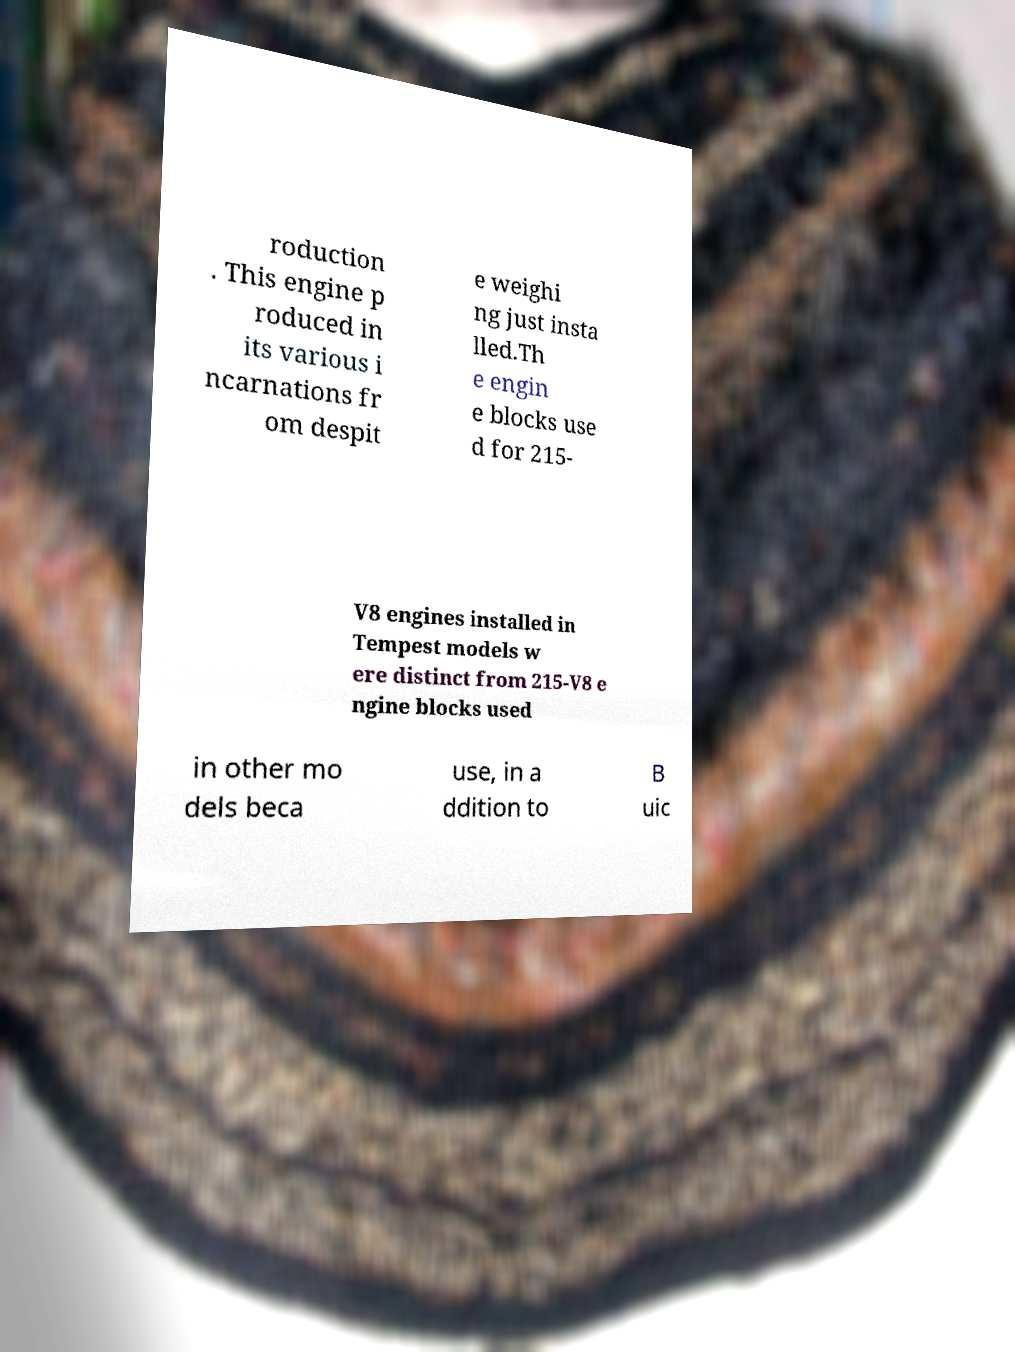Please identify and transcribe the text found in this image. roduction . This engine p roduced in its various i ncarnations fr om despit e weighi ng just insta lled.Th e engin e blocks use d for 215- V8 engines installed in Tempest models w ere distinct from 215-V8 e ngine blocks used in other mo dels beca use, in a ddition to B uic 